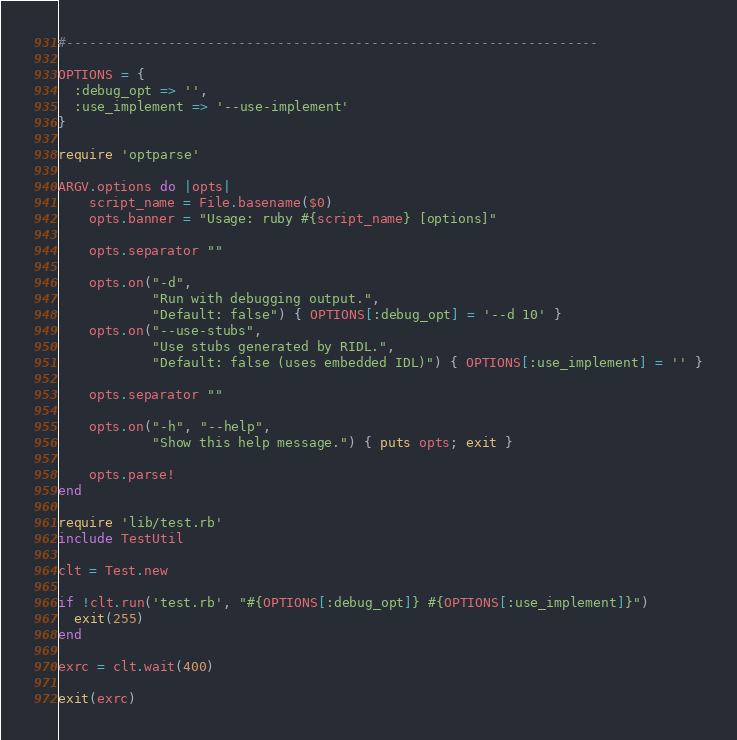<code> <loc_0><loc_0><loc_500><loc_500><_Ruby_>#--------------------------------------------------------------------

OPTIONS = {
  :debug_opt => '',
  :use_implement => '--use-implement'
}

require 'optparse'

ARGV.options do |opts|
    script_name = File.basename($0)
    opts.banner = "Usage: ruby #{script_name} [options]"

    opts.separator ""

    opts.on("-d",
            "Run with debugging output.",
            "Default: false") { OPTIONS[:debug_opt] = '--d 10' }
    opts.on("--use-stubs",
            "Use stubs generated by RIDL.",
            "Default: false (uses embedded IDL)") { OPTIONS[:use_implement] = '' }

    opts.separator ""

    opts.on("-h", "--help",
            "Show this help message.") { puts opts; exit }

    opts.parse!
end

require 'lib/test.rb'
include TestUtil

clt = Test.new

if !clt.run('test.rb', "#{OPTIONS[:debug_opt]} #{OPTIONS[:use_implement]}")
  exit(255)
end

exrc = clt.wait(400)

exit(exrc)
</code> 